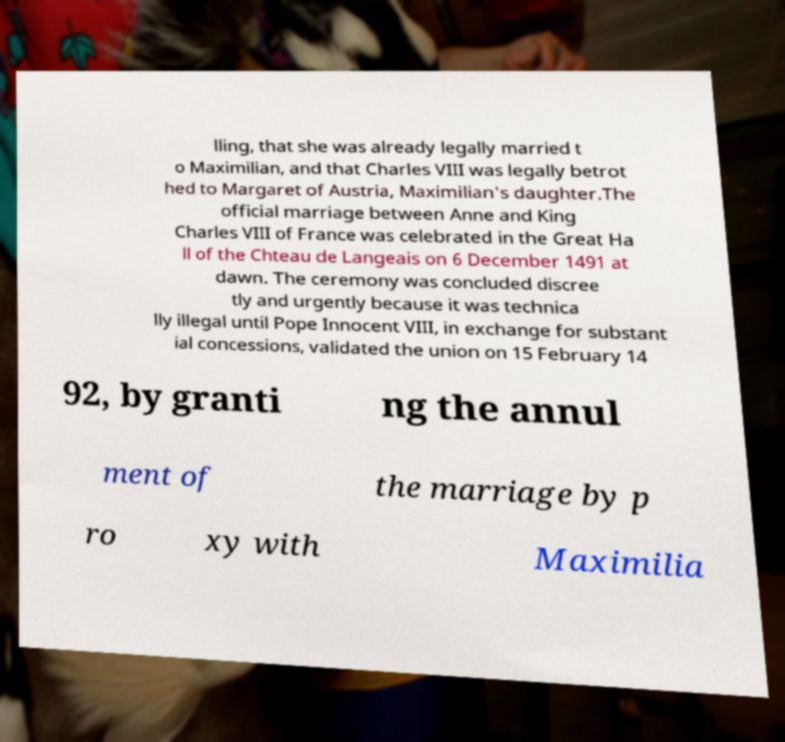Please identify and transcribe the text found in this image. lling, that she was already legally married t o Maximilian, and that Charles VIII was legally betrot hed to Margaret of Austria, Maximilian's daughter.The official marriage between Anne and King Charles VIII of France was celebrated in the Great Ha ll of the Chteau de Langeais on 6 December 1491 at dawn. The ceremony was concluded discree tly and urgently because it was technica lly illegal until Pope Innocent VIII, in exchange for substant ial concessions, validated the union on 15 February 14 92, by granti ng the annul ment of the marriage by p ro xy with Maximilia 